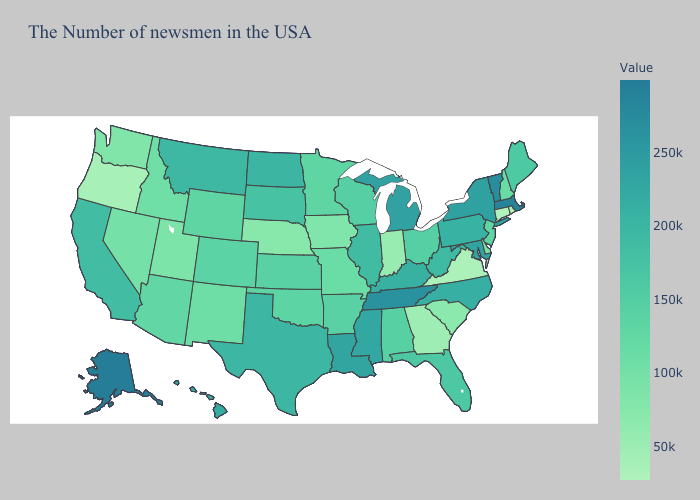Which states have the highest value in the USA?
Answer briefly. Alaska. Among the states that border Oklahoma , does Arkansas have the lowest value?
Answer briefly. No. Does West Virginia have a lower value than Georgia?
Concise answer only. No. Does Connecticut have the lowest value in the USA?
Concise answer only. Yes. Which states have the lowest value in the USA?
Give a very brief answer. Connecticut. Does Indiana have the lowest value in the MidWest?
Short answer required. Yes. Does Oregon have the highest value in the West?
Quick response, please. No. Does the map have missing data?
Give a very brief answer. No. Does Kansas have the highest value in the MidWest?
Give a very brief answer. No. 